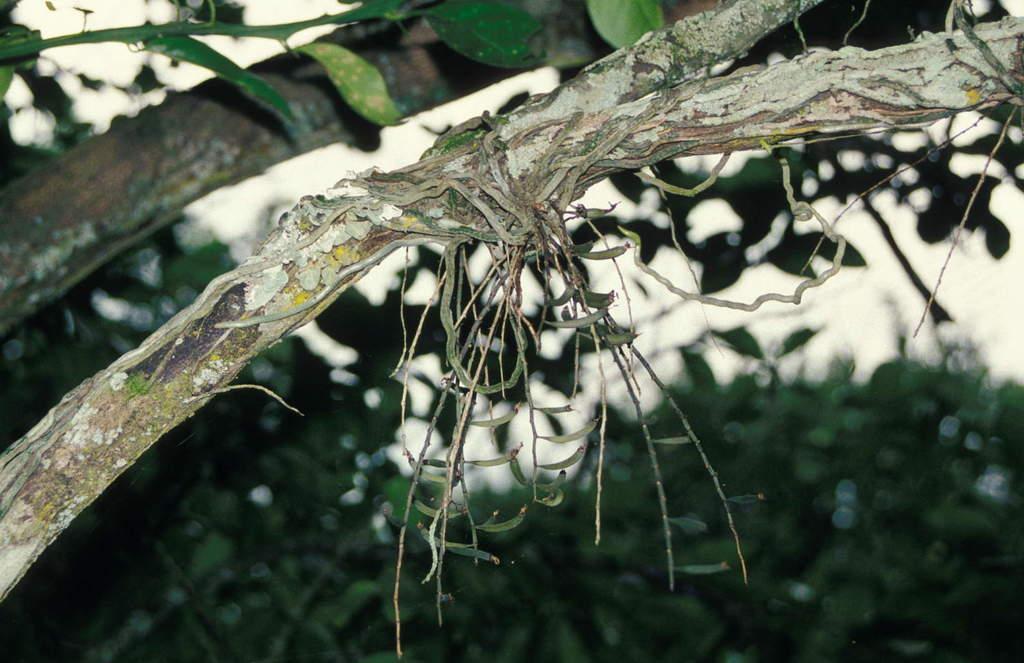Please provide a concise description of this image. In this image we can see a tree, here is the branch, here are the leaves, at background it is blurry. 